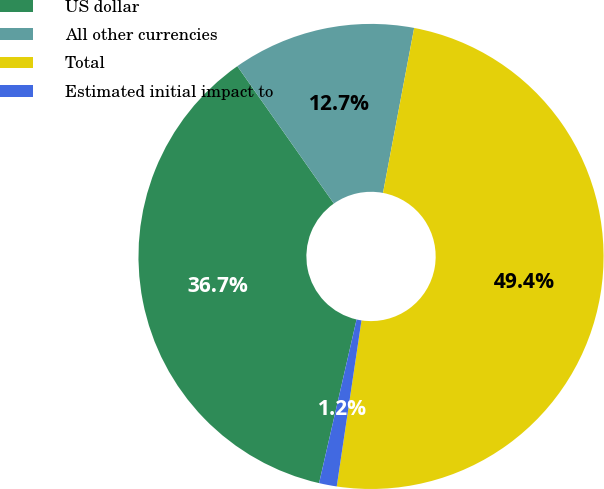Convert chart. <chart><loc_0><loc_0><loc_500><loc_500><pie_chart><fcel>US dollar<fcel>All other currencies<fcel>Total<fcel>Estimated initial impact to<nl><fcel>36.67%<fcel>12.72%<fcel>49.39%<fcel>1.23%<nl></chart> 